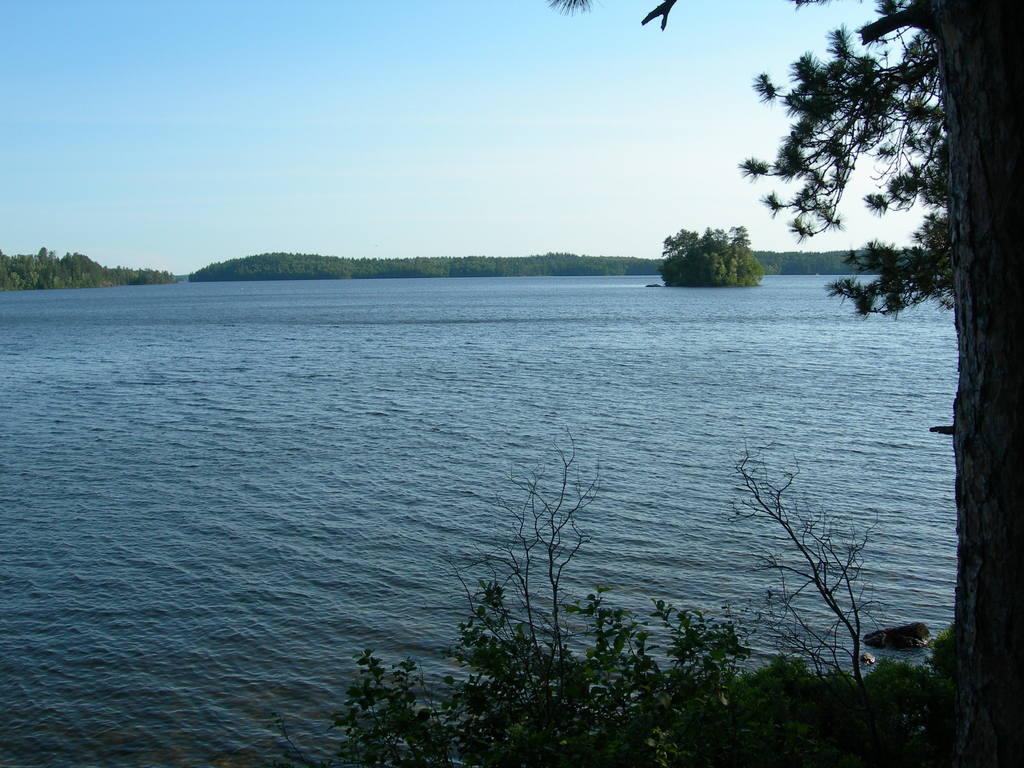Describe this image in one or two sentences. In this image at the bottom there is a river and in the foreground there are some plants and trees. In the background there are some mountains and trees, on the top of the image there is sky. 